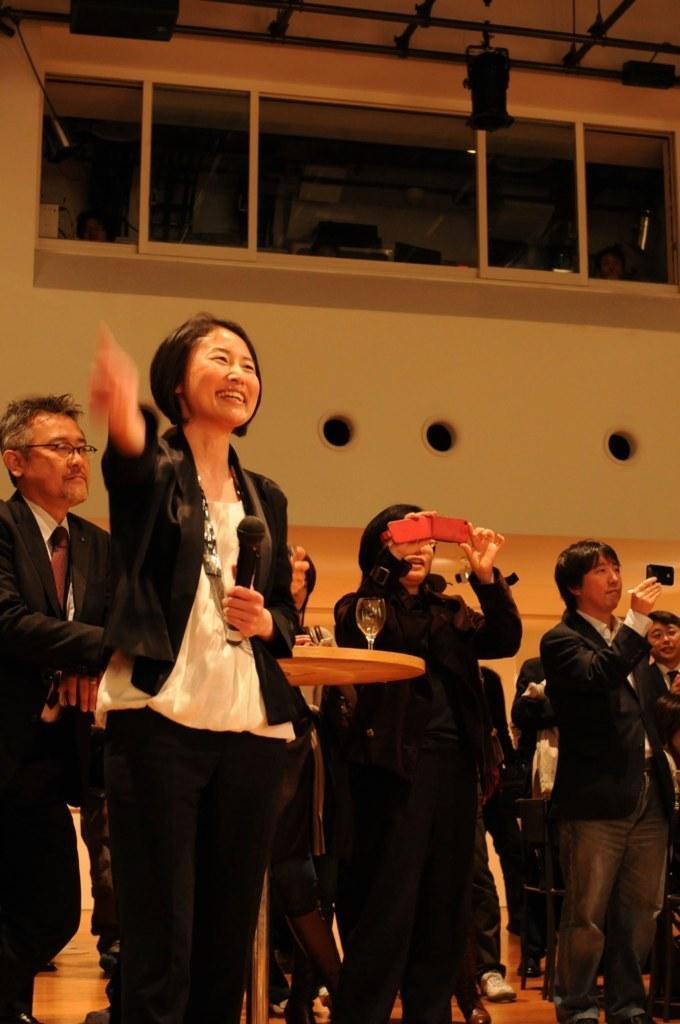Please provide a concise description of this image. In the foreground of this image, there is a woman standing and holding a mic. Behind her, there is a man and a woman standing near a table on which there is a glass and the woman is holding a mobile. In the background, there are people standing, a table on the floor, a wall, glass windows and the lights at the top. 